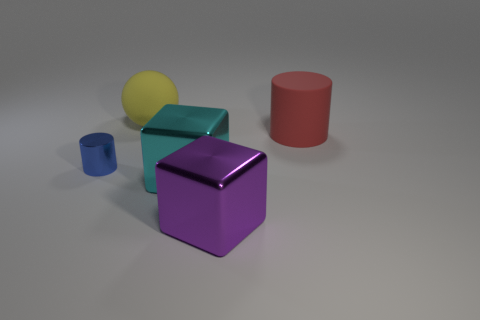There is a shiny thing left of the big cyan shiny block; is its shape the same as the red rubber thing?
Your answer should be compact. Yes. Are the large cube to the right of the cyan thing and the cylinder behind the small blue cylinder made of the same material?
Provide a short and direct response. No. What is the color of the big sphere?
Give a very brief answer. Yellow. How many blue things are the same shape as the big red matte thing?
Offer a terse response. 1. There is a sphere that is the same size as the red cylinder; what is its color?
Your answer should be very brief. Yellow. Are there any red matte cylinders?
Your answer should be compact. Yes. What shape is the thing on the left side of the yellow rubber ball?
Give a very brief answer. Cylinder. What number of objects are both right of the blue thing and in front of the large red thing?
Your answer should be compact. 2. Are there any yellow balls that have the same material as the big red cylinder?
Your answer should be very brief. Yes. How many balls are either rubber things or small blue metallic objects?
Ensure brevity in your answer.  1. 